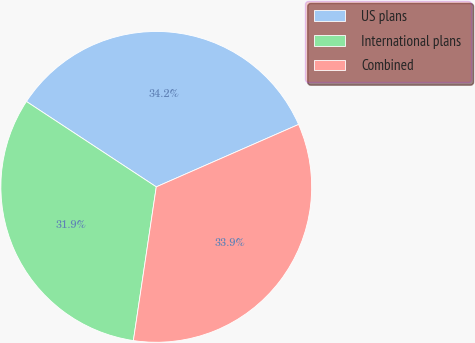Convert chart to OTSL. <chart><loc_0><loc_0><loc_500><loc_500><pie_chart><fcel>US plans<fcel>International plans<fcel>Combined<nl><fcel>34.16%<fcel>31.9%<fcel>33.93%<nl></chart> 